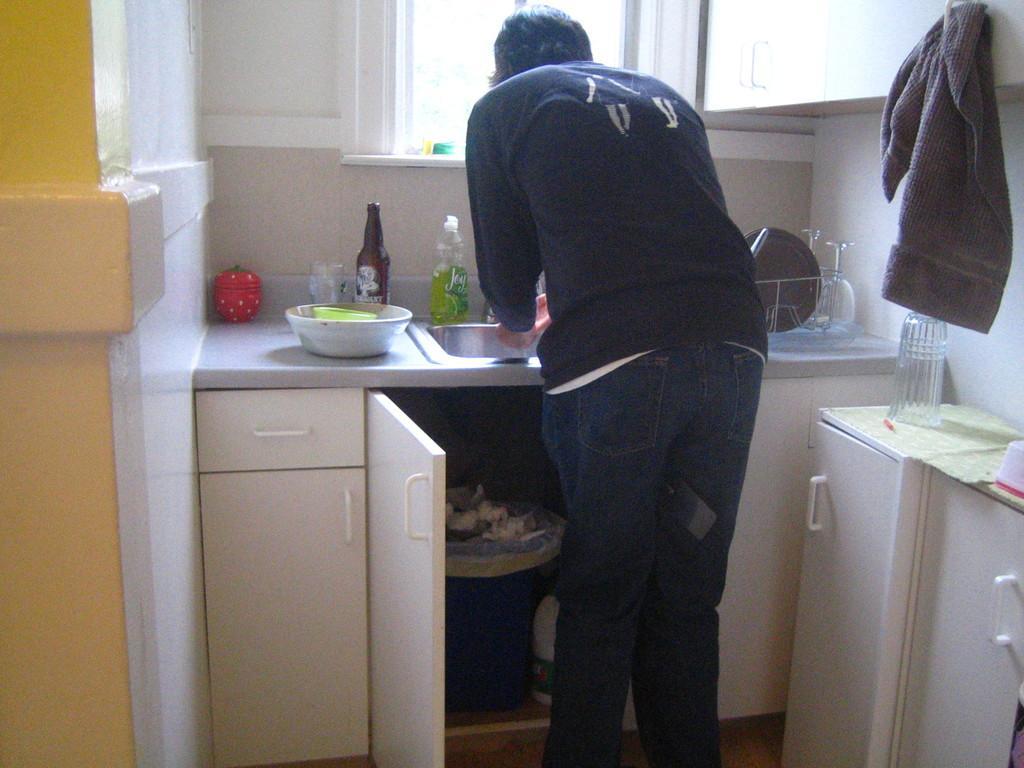Please provide a concise description of this image. The woman in blue T-shirt is washing her hands. In front of her, we see a counter top on which bowl, glass bottle, red color box and plates are placed. Beside that, we see a cupboard on which glass is placed. At the top of the picture, we see a cupboard and a window. On the left corner of the picture, we see a wall in white color. This picture is clicked inside the room. 